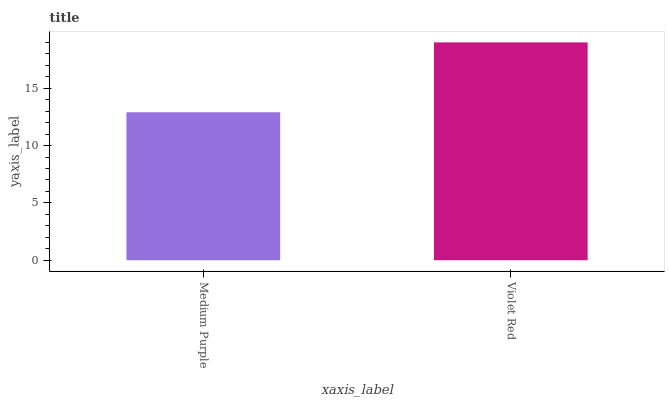Is Medium Purple the minimum?
Answer yes or no. Yes. Is Violet Red the maximum?
Answer yes or no. Yes. Is Violet Red the minimum?
Answer yes or no. No. Is Violet Red greater than Medium Purple?
Answer yes or no. Yes. Is Medium Purple less than Violet Red?
Answer yes or no. Yes. Is Medium Purple greater than Violet Red?
Answer yes or no. No. Is Violet Red less than Medium Purple?
Answer yes or no. No. Is Violet Red the high median?
Answer yes or no. Yes. Is Medium Purple the low median?
Answer yes or no. Yes. Is Medium Purple the high median?
Answer yes or no. No. Is Violet Red the low median?
Answer yes or no. No. 